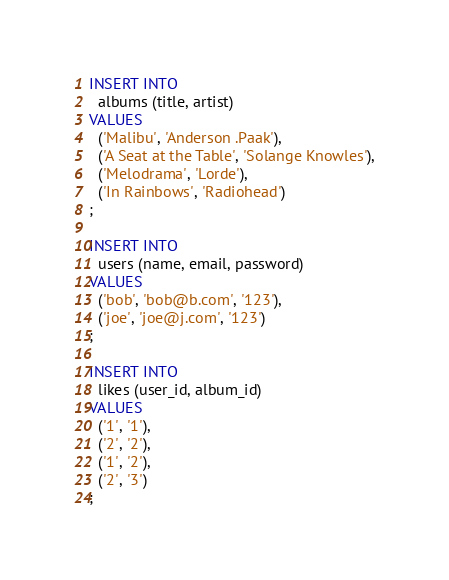Convert code to text. <code><loc_0><loc_0><loc_500><loc_500><_SQL_>INSERT INTO
  albums (title, artist)
VALUES
  ('Malibu', 'Anderson .Paak'),
  ('A Seat at the Table', 'Solange Knowles'),
  ('Melodrama', 'Lorde'),
  ('In Rainbows', 'Radiohead')
;

INSERT INTO
  users (name, email, password)
VALUES
  ('bob', 'bob@b.com', '123'),
  ('joe', 'joe@j.com', '123')
;

INSERT INTO
  likes (user_id, album_id)
VALUES
  ('1', '1'),
  ('2', '2'),
  ('1', '2'),
  ('2', '3')
;
</code> 